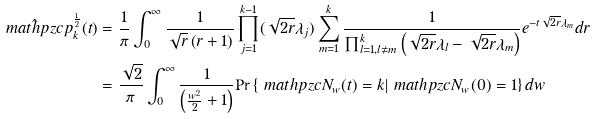<formula> <loc_0><loc_0><loc_500><loc_500>\hat { \ m a t h p z c { p } } _ { k } ^ { \frac { 1 } { 2 } } ( t ) & = \frac { 1 } { \pi } \int _ { 0 } ^ { \infty } \frac { 1 } { \sqrt { r } \left ( r + 1 \right ) } \prod _ { j = 1 } ^ { k - 1 } ( \sqrt { 2 r } \lambda _ { j } ) \sum _ { m = 1 } ^ { k } \frac { 1 } { \prod _ { l = 1 , l \neq m } ^ { k } \left ( \sqrt { 2 r } \lambda _ { l } - \sqrt { 2 r } \lambda _ { m } \right ) } e ^ { - t \sqrt { 2 r } \lambda _ { m } } d r \\ & = \frac { \sqrt { 2 } } { \pi } \int _ { 0 } ^ { \infty } \frac { 1 } { \left ( \frac { w ^ { 2 } } { 2 } + 1 \right ) } \text {Pr} \left \{ \ m a t h p z c { N } _ { w } ( t ) = k | \ m a t h p z c { N } _ { w } ( 0 ) = 1 \right \} d w</formula> 